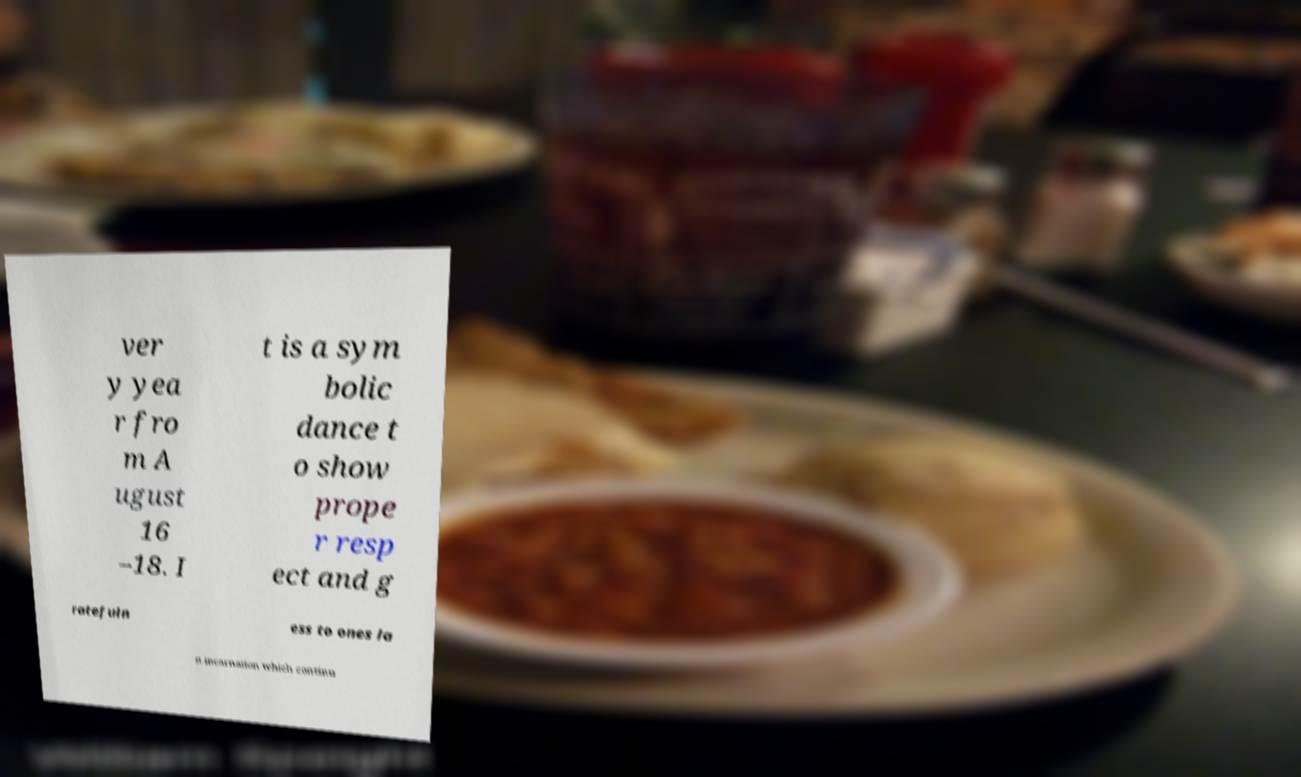Can you accurately transcribe the text from the provided image for me? ver y yea r fro m A ugust 16 –18. I t is a sym bolic dance t o show prope r resp ect and g ratefuln ess to ones la st incarnation which continu 